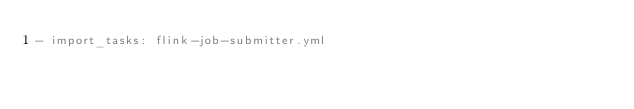<code> <loc_0><loc_0><loc_500><loc_500><_YAML_>- import_tasks: flink-job-submitter.yml</code> 